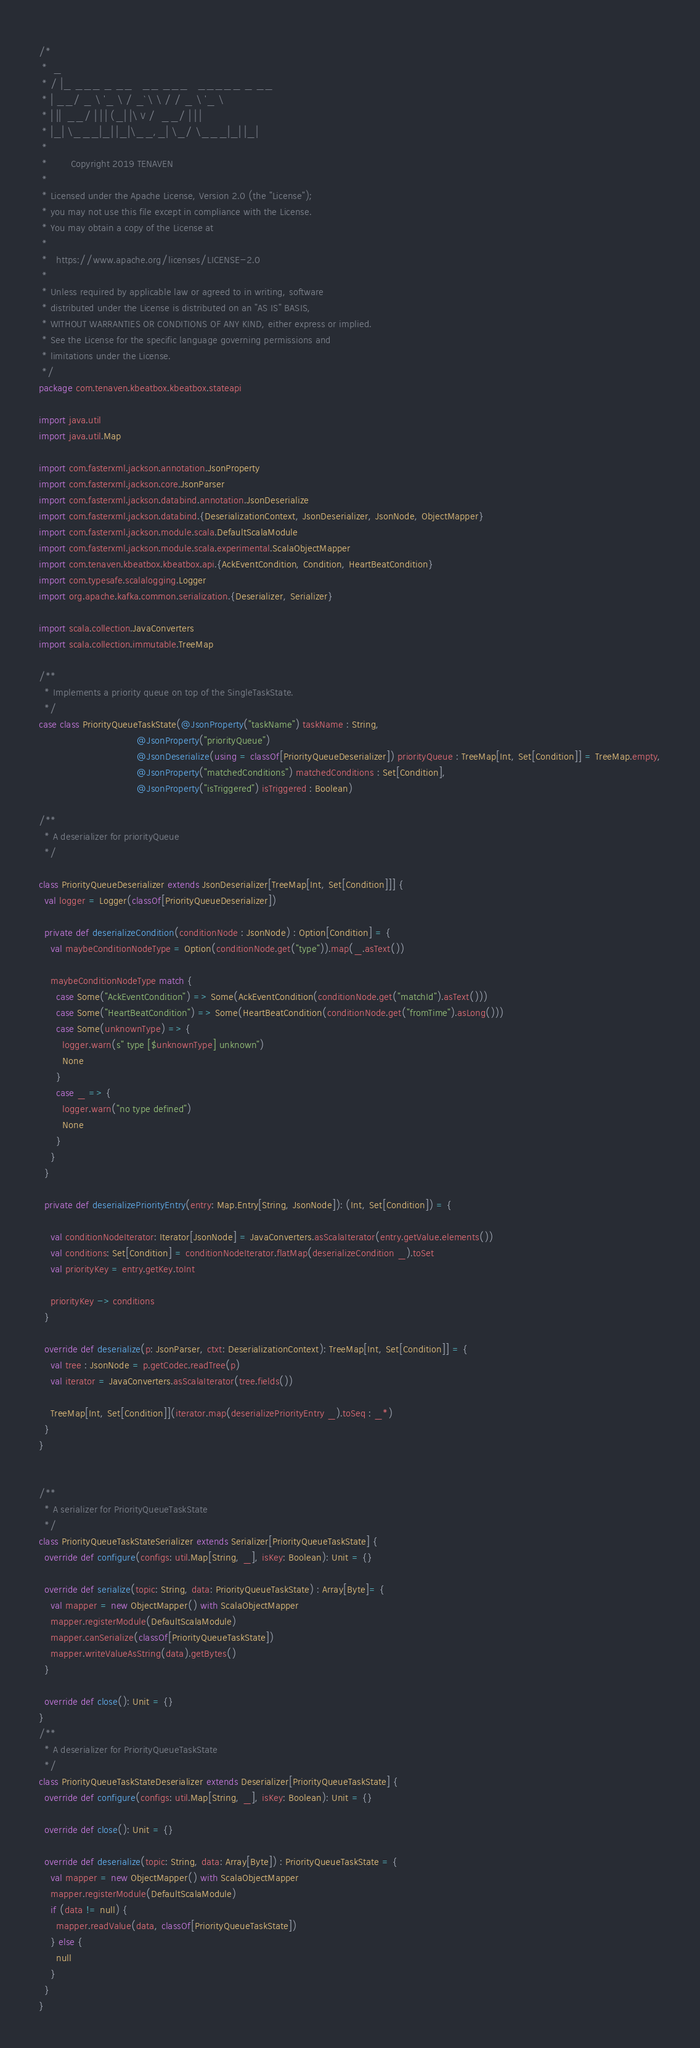<code> <loc_0><loc_0><loc_500><loc_500><_Scala_>/*
 *  _
 * / |_ ___ _ __   __ ___   _____ _ __
 * | __/ _ \ '_ \ / _` \ \ / / _ \ '_ \
 * | ||  __/ | | | (_| |\ V /  __/ | | |
 * |_| \___|_| |_|\__,_| \_/ \___|_| |_|
 *
 *        Copyright 2019 TENAVEN
 *
 * Licensed under the Apache License, Version 2.0 (the "License");
 * you may not use this file except in compliance with the License.
 * You may obtain a copy of the License at
 *
 *   https://www.apache.org/licenses/LICENSE-2.0
 *
 * Unless required by applicable law or agreed to in writing, software
 * distributed under the License is distributed on an "AS IS" BASIS,
 * WITHOUT WARRANTIES OR CONDITIONS OF ANY KIND, either express or implied.
 * See the License for the specific language governing permissions and
 * limitations under the License.
 */
package com.tenaven.kbeatbox.kbeatbox.stateapi

import java.util
import java.util.Map

import com.fasterxml.jackson.annotation.JsonProperty
import com.fasterxml.jackson.core.JsonParser
import com.fasterxml.jackson.databind.annotation.JsonDeserialize
import com.fasterxml.jackson.databind.{DeserializationContext, JsonDeserializer, JsonNode, ObjectMapper}
import com.fasterxml.jackson.module.scala.DefaultScalaModule
import com.fasterxml.jackson.module.scala.experimental.ScalaObjectMapper
import com.tenaven.kbeatbox.kbeatbox.api.{AckEventCondition, Condition, HeartBeatCondition}
import com.typesafe.scalalogging.Logger
import org.apache.kafka.common.serialization.{Deserializer, Serializer}

import scala.collection.JavaConverters
import scala.collection.immutable.TreeMap

/**
  * Implements a priority queue on top of the SingleTaskState.
  */
case class PriorityQueueTaskState(@JsonProperty("taskName") taskName : String,
                                  @JsonProperty("priorityQueue")
                                  @JsonDeserialize(using = classOf[PriorityQueueDeserializer]) priorityQueue : TreeMap[Int, Set[Condition]] = TreeMap.empty,
                                  @JsonProperty("matchedConditions") matchedConditions : Set[Condition],
                                  @JsonProperty("isTriggered") isTriggered : Boolean)

/**
  * A deserializer for priorityQueue
  */

class PriorityQueueDeserializer extends JsonDeserializer[TreeMap[Int, Set[Condition]]] {
  val logger = Logger(classOf[PriorityQueueDeserializer])

  private def deserializeCondition(conditionNode : JsonNode) : Option[Condition] = {
    val maybeConditionNodeType = Option(conditionNode.get("type")).map(_.asText())

    maybeConditionNodeType match {
      case Some("AckEventCondition") => Some(AckEventCondition(conditionNode.get("matchId").asText()))
      case Some("HeartBeatCondition") => Some(HeartBeatCondition(conditionNode.get("fromTime").asLong()))
      case Some(unknownType) => {
        logger.warn(s" type [$unknownType] unknown")
        None
      }
      case _ => {
        logger.warn("no type defined")
        None
      }
    }
  }

  private def deserializePriorityEntry(entry: Map.Entry[String, JsonNode]): (Int, Set[Condition]) = {

    val conditionNodeIterator: Iterator[JsonNode] = JavaConverters.asScalaIterator(entry.getValue.elements())
    val conditions: Set[Condition] = conditionNodeIterator.flatMap(deserializeCondition _).toSet
    val priorityKey = entry.getKey.toInt

    priorityKey -> conditions
  }

  override def deserialize(p: JsonParser, ctxt: DeserializationContext): TreeMap[Int, Set[Condition]] = {
    val tree : JsonNode = p.getCodec.readTree(p)
    val iterator = JavaConverters.asScalaIterator(tree.fields())

    TreeMap[Int, Set[Condition]](iterator.map(deserializePriorityEntry _).toSeq : _*)
  }
}


/**
  * A serializer for PriorityQueueTaskState
  */
class PriorityQueueTaskStateSerializer extends Serializer[PriorityQueueTaskState] {
  override def configure(configs: util.Map[String, _], isKey: Boolean): Unit = {}

  override def serialize(topic: String, data: PriorityQueueTaskState) : Array[Byte]= {
    val mapper = new ObjectMapper() with ScalaObjectMapper
    mapper.registerModule(DefaultScalaModule)
    mapper.canSerialize(classOf[PriorityQueueTaskState])
    mapper.writeValueAsString(data).getBytes()
  }

  override def close(): Unit = {}
}
/**
  * A deserializer for PriorityQueueTaskState
  */
class PriorityQueueTaskStateDeserializer extends Deserializer[PriorityQueueTaskState] {
  override def configure(configs: util.Map[String, _], isKey: Boolean): Unit = {}

  override def close(): Unit = {}

  override def deserialize(topic: String, data: Array[Byte]) : PriorityQueueTaskState = {
    val mapper = new ObjectMapper() with ScalaObjectMapper
    mapper.registerModule(DefaultScalaModule)
    if (data != null) {
      mapper.readValue(data, classOf[PriorityQueueTaskState])
    } else {
      null
    }
  }
}</code> 